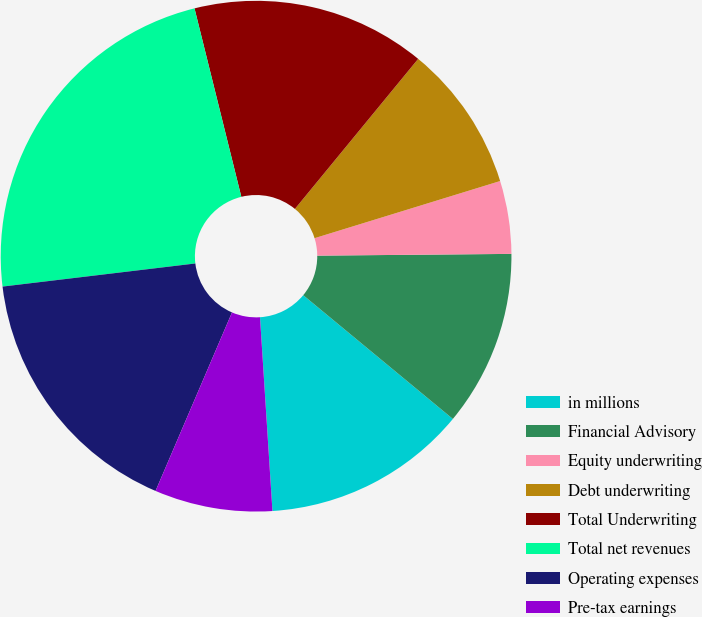Convert chart to OTSL. <chart><loc_0><loc_0><loc_500><loc_500><pie_chart><fcel>in millions<fcel>Financial Advisory<fcel>Equity underwriting<fcel>Debt underwriting<fcel>Total Underwriting<fcel>Total net revenues<fcel>Operating expenses<fcel>Pre-tax earnings<nl><fcel>12.98%<fcel>11.14%<fcel>4.61%<fcel>9.3%<fcel>14.82%<fcel>23.02%<fcel>16.66%<fcel>7.46%<nl></chart> 